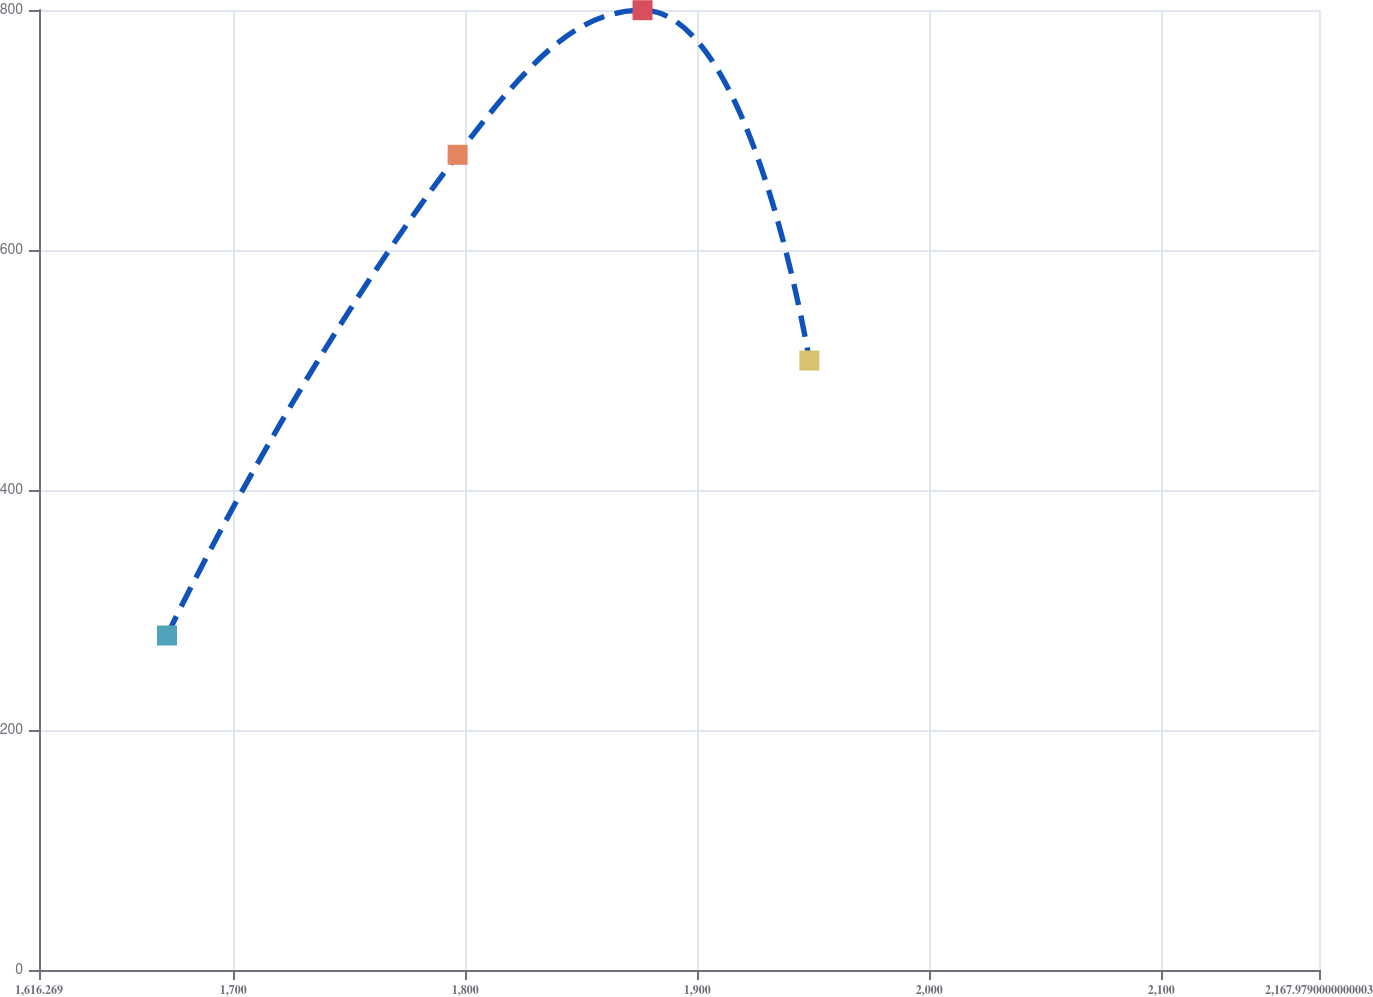<chart> <loc_0><loc_0><loc_500><loc_500><line_chart><ecel><fcel>Unnamed: 1<nl><fcel>1671.44<fcel>278.72<nl><fcel>1796.7<fcel>679.34<nl><fcel>1876.4<fcel>799.82<nl><fcel>1948.33<fcel>507.89<nl><fcel>2223.15<fcel>419.67<nl></chart> 